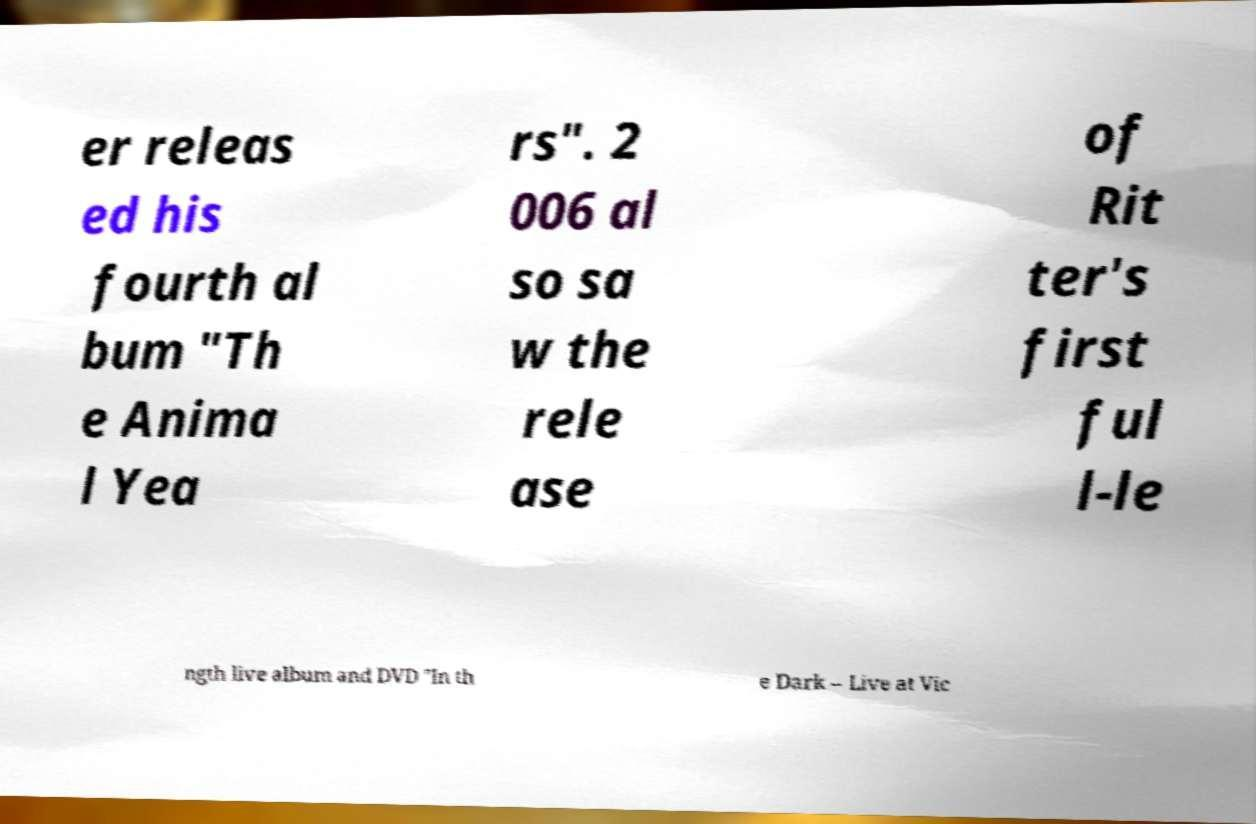For documentation purposes, I need the text within this image transcribed. Could you provide that? er releas ed his fourth al bum "Th e Anima l Yea rs". 2 006 al so sa w the rele ase of Rit ter's first ful l-le ngth live album and DVD "In th e Dark – Live at Vic 